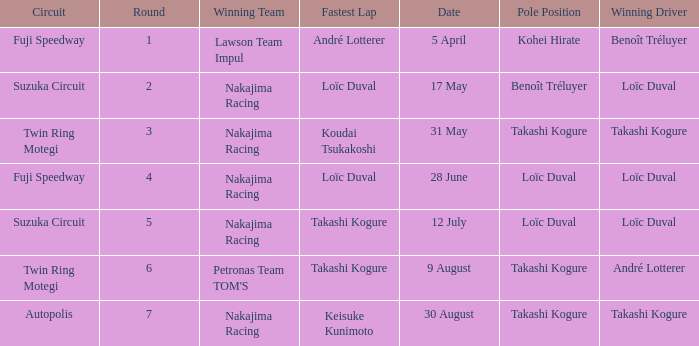How many drivers drove on Suzuka Circuit where Loïc Duval took pole position? 1.0. 